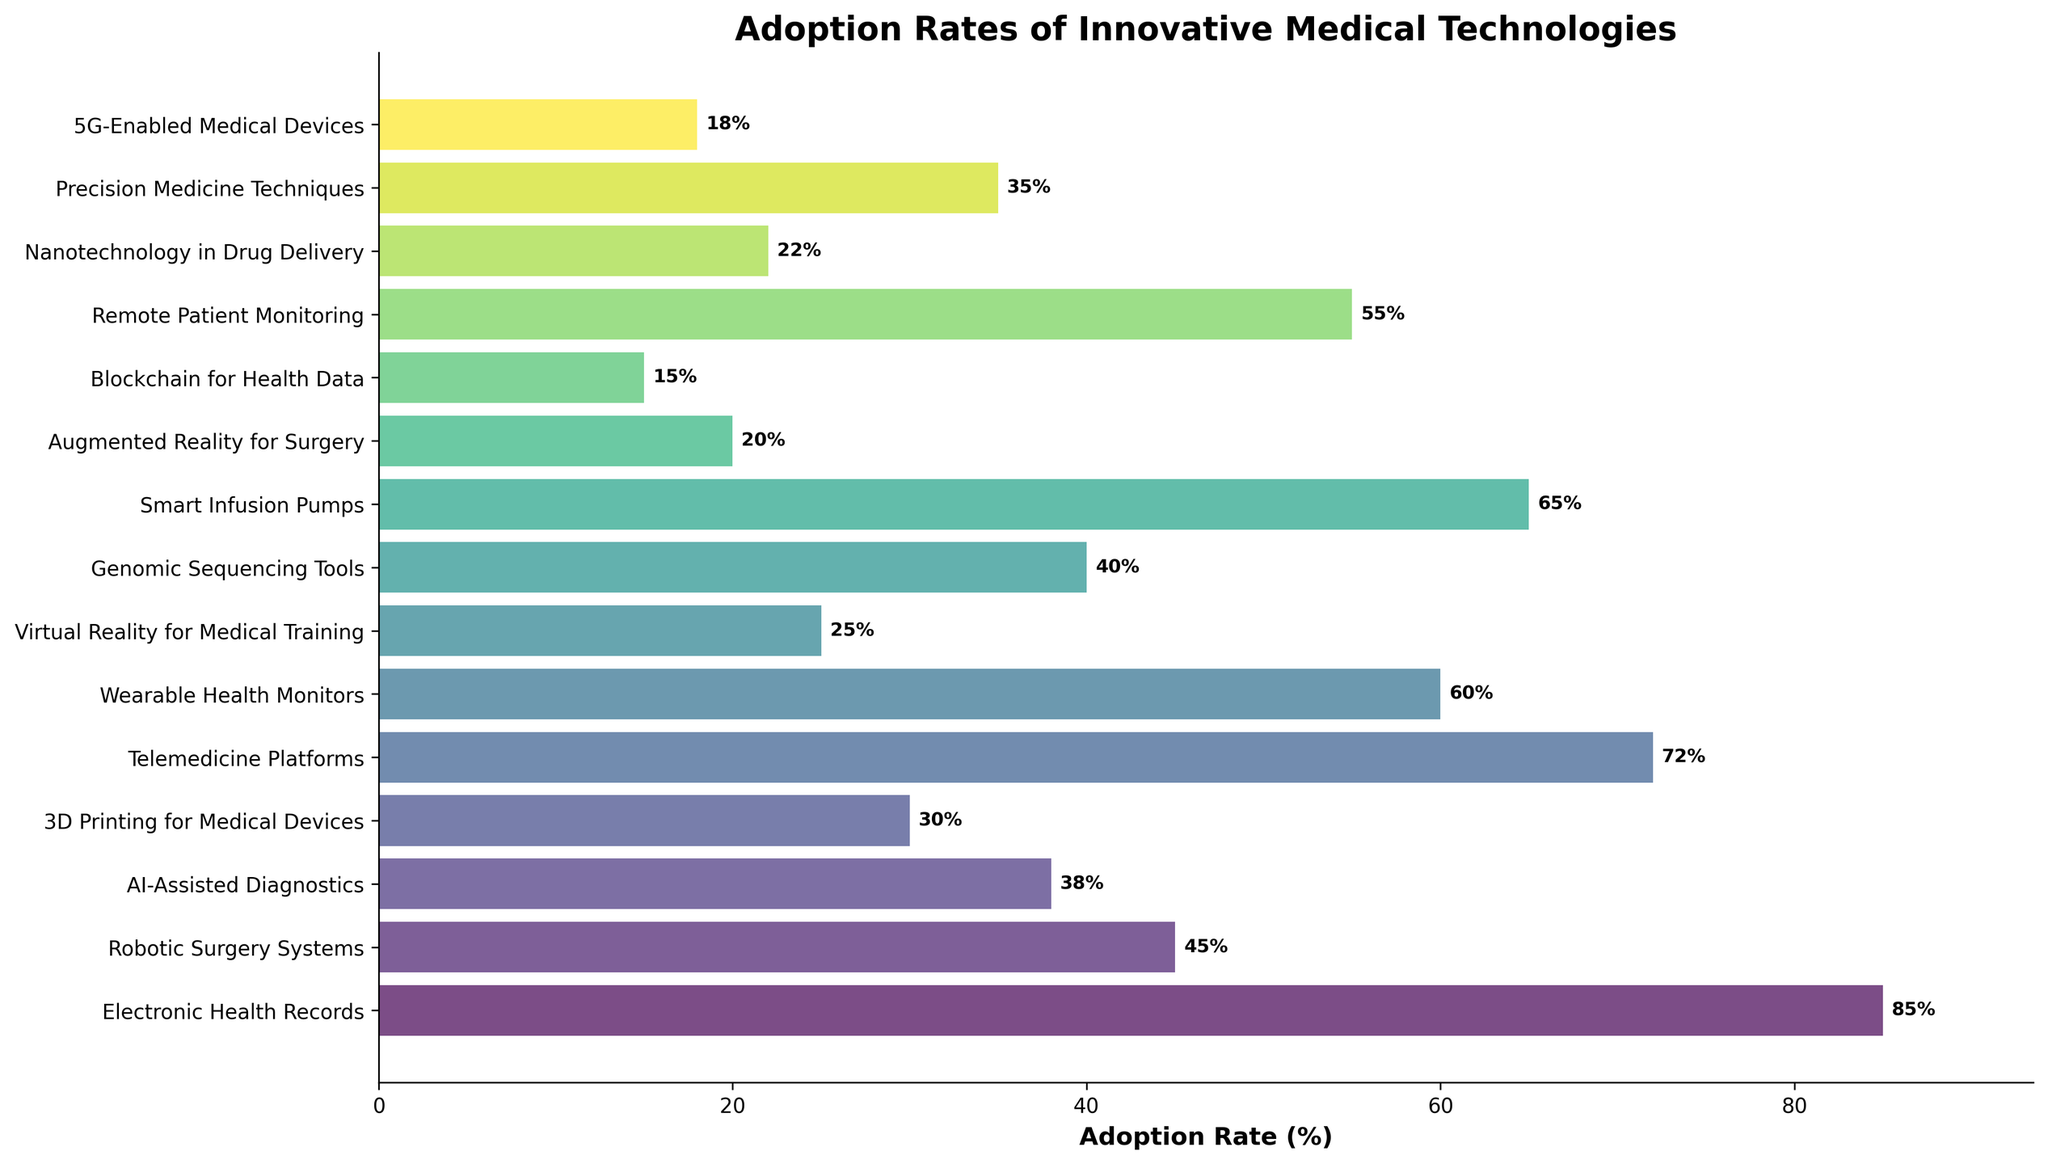What is the adoption rate of Electronic Health Records? The adoption rate is given directly in the figure, which is 85%.
Answer: 85% Which technology has the highest adoption rate? By observing the length of the bars, Electronic Health Records have the longest bar, indicating the highest adoption rate.
Answer: Electronic Health Records Compare the adoption rates of 3D Printing for Medical Devices and Blockchain for Health Data. Which one is higher? The adoption rate of 3D Printing for Medical Devices is 30%, and for Blockchain for Health Data, it is 15%. Thus, 3D Printing for Medical Devices has a higher adoption rate.
Answer: 3D Printing for Medical Devices What is the total adoption rate for the top three technologies? The top three technologies based on adoption rates are Electronic Health Records (85%), Telemedicine Platforms (72%), and Smart Infusion Pumps (65%). Summing these up gives 85 + 72 + 65 = 222%.
Answer: 222% Which technology has a lower adoption rate: Virtual Reality for Medical Training or Augmented Reality for Surgery? The adoption rate for Virtual Reality for Medical Training is 25%, while for Augmented Reality for Surgery, it is 20%. Therefore, Augmented Reality for Surgery has a lower adoption rate.
Answer: Augmented Reality for Surgery What is the difference in adoption rates between Wearable Health Monitors and Remote Patient Monitoring? The adoption rate for Wearable Health Monitors is 60%, while for Remote Patient Monitoring, it is 55%. The difference is 60 - 55 = 5%.
Answer: 5% Find the average adoption rate of AI-Assisted Diagnostics, Genomic Sequencing Tools, and Precision Medicine Techniques. The adoption rates are 38% for AI-Assisted Diagnostics, 40% for Genomic Sequencing Tools, and 35% for Precision Medicine Techniques. The average is (38 + 40 + 35) / 3 = 113 / 3 ≈ 37.67%.
Answer: 37.67% Identify the two technologies with adoption rates closest to 25%. The technologies with adoption rates closest to 25% are Virtual Reality for Medical Training at 25% and Nanotechnology in Drug Delivery at 22%.
Answer: Virtual Reality for Medical Training, Nanotechnology in Drug Delivery 